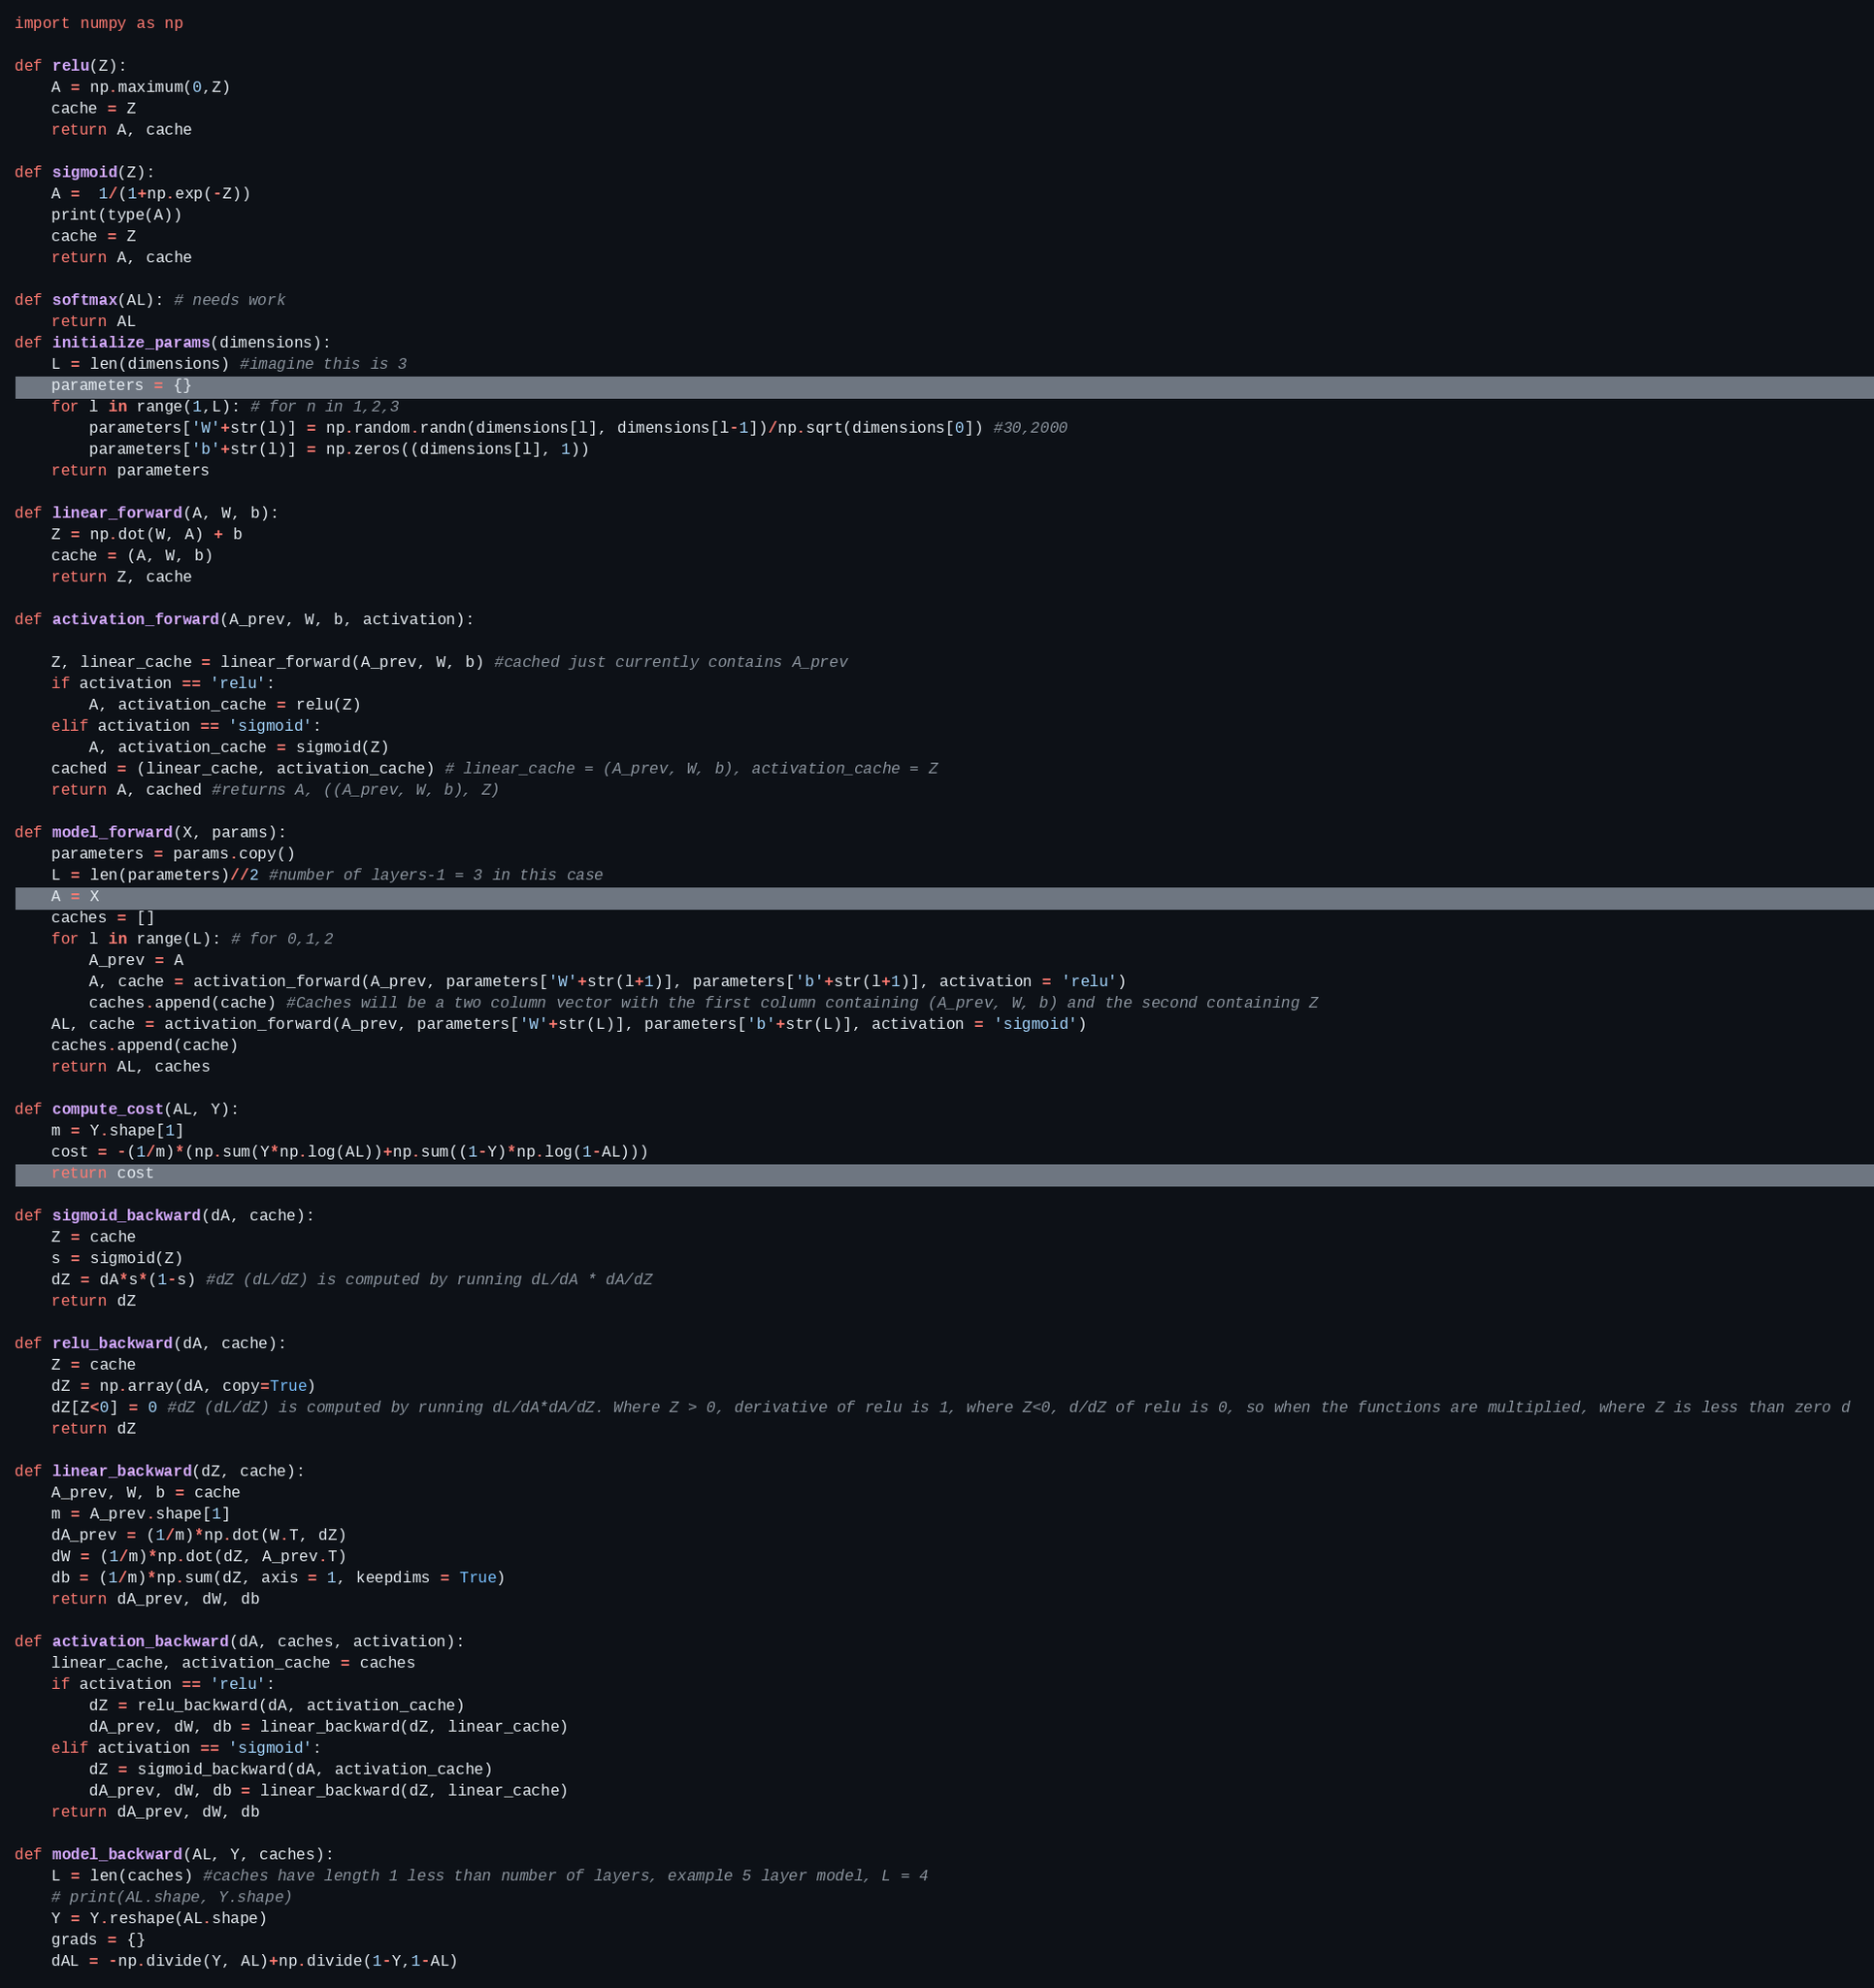<code> <loc_0><loc_0><loc_500><loc_500><_Python_>import numpy as np

def relu(Z):
    A = np.maximum(0,Z)
    cache = Z
    return A, cache

def sigmoid(Z):
    A =  1/(1+np.exp(-Z))
    print(type(A))
    cache = Z
    return A, cache

def softmax(AL): # needs work
    return AL
def initialize_params(dimensions):
    L = len(dimensions) #imagine this is 3
    parameters = {}
    for l in range(1,L): # for n in 1,2,3
        parameters['W'+str(l)] = np.random.randn(dimensions[l], dimensions[l-1])/np.sqrt(dimensions[0]) #30,2000
        parameters['b'+str(l)] = np.zeros((dimensions[l], 1))
    return parameters

def linear_forward(A, W, b):
    Z = np.dot(W, A) + b 
    cache = (A, W, b)
    return Z, cache

def activation_forward(A_prev, W, b, activation):
    
    Z, linear_cache = linear_forward(A_prev, W, b) #cached just currently contains A_prev
    if activation == 'relu':
        A, activation_cache = relu(Z)
    elif activation == 'sigmoid':
        A, activation_cache = sigmoid(Z)
    cached = (linear_cache, activation_cache) # linear_cache = (A_prev, W, b), activation_cache = Z
    return A, cached #returns A, ((A_prev, W, b), Z)

def model_forward(X, params):
    parameters = params.copy()
    L = len(parameters)//2 #number of layers-1 = 3 in this case
    A = X
    caches = []
    for l in range(L): # for 0,1,2
        A_prev = A
        A, cache = activation_forward(A_prev, parameters['W'+str(l+1)], parameters['b'+str(l+1)], activation = 'relu')
        caches.append(cache) #Caches will be a two column vector with the first column containing (A_prev, W, b) and the second containing Z
    AL, cache = activation_forward(A_prev, parameters['W'+str(L)], parameters['b'+str(L)], activation = 'sigmoid')
    caches.append(cache)
    return AL, caches

def compute_cost(AL, Y):
    m = Y.shape[1]
    cost = -(1/m)*(np.sum(Y*np.log(AL))+np.sum((1-Y)*np.log(1-AL)))
    return cost

def sigmoid_backward(dA, cache):
    Z = cache
    s = sigmoid(Z)
    dZ = dA*s*(1-s) #dZ (dL/dZ) is computed by running dL/dA * dA/dZ
    return dZ

def relu_backward(dA, cache):
    Z = cache
    dZ = np.array(dA, copy=True)
    dZ[Z<0] = 0 #dZ (dL/dZ) is computed by running dL/dA*dA/dZ. Where Z > 0, derivative of relu is 1, where Z<0, d/dZ of relu is 0, so when the functions are multiplied, where Z is less than zero d 
    return dZ

def linear_backward(dZ, cache): 
    A_prev, W, b = cache
    m = A_prev.shape[1]
    dA_prev = (1/m)*np.dot(W.T, dZ) 
    dW = (1/m)*np.dot(dZ, A_prev.T)
    db = (1/m)*np.sum(dZ, axis = 1, keepdims = True)
    return dA_prev, dW, db

def activation_backward(dA, caches, activation):
    linear_cache, activation_cache = caches
    if activation == 'relu':
        dZ = relu_backward(dA, activation_cache)
        dA_prev, dW, db = linear_backward(dZ, linear_cache)
    elif activation == 'sigmoid':
        dZ = sigmoid_backward(dA, activation_cache)
        dA_prev, dW, db = linear_backward(dZ, linear_cache)
    return dA_prev, dW, db 

def model_backward(AL, Y, caches): 
    L = len(caches) #caches have length 1 less than number of layers, example 5 layer model, L = 4
    # print(AL.shape, Y.shape)
    Y = Y.reshape(AL.shape)
    grads = {}
    dAL = -np.divide(Y, AL)+np.divide(1-Y,1-AL)</code> 